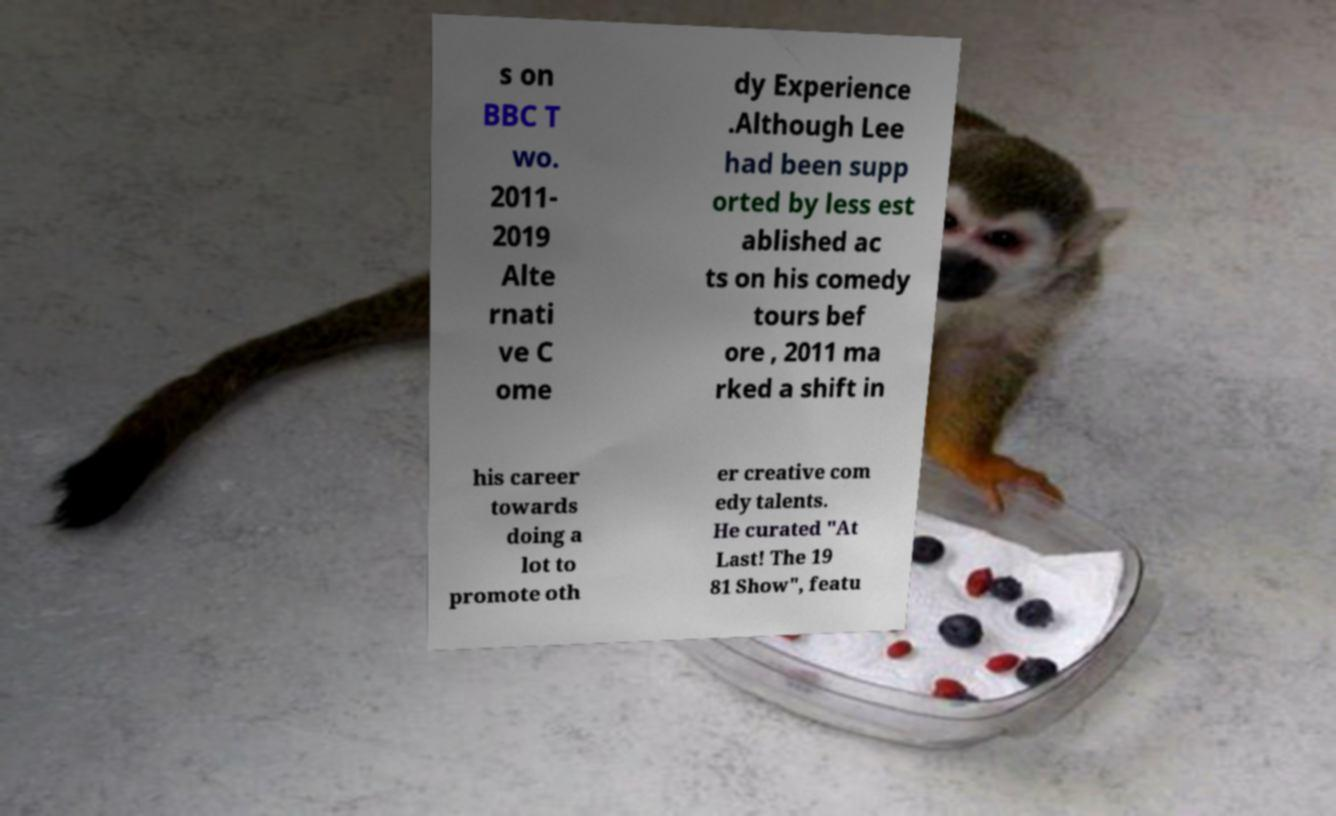Can you read and provide the text displayed in the image?This photo seems to have some interesting text. Can you extract and type it out for me? s on BBC T wo. 2011- 2019 Alte rnati ve C ome dy Experience .Although Lee had been supp orted by less est ablished ac ts on his comedy tours bef ore , 2011 ma rked a shift in his career towards doing a lot to promote oth er creative com edy talents. He curated "At Last! The 19 81 Show", featu 